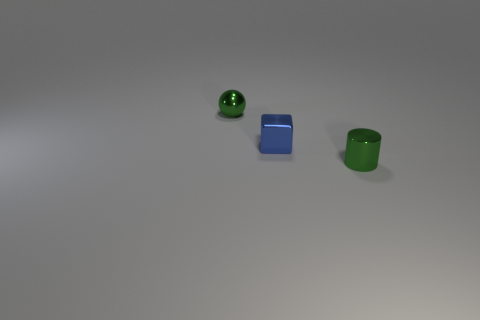What is the size of the object that is the same color as the tiny cylinder?
Your response must be concise. Small. There is a green metallic object on the right side of the metal ball; what number of objects are behind it?
Offer a very short reply. 2. What number of yellow objects are either shiny balls or rubber cylinders?
Give a very brief answer. 0. There is a small green metallic object that is to the left of the tiny green object in front of the green shiny thing to the left of the green cylinder; what shape is it?
Give a very brief answer. Sphere. What color is the cube that is the same size as the green metallic cylinder?
Offer a very short reply. Blue. How many other blue objects are the same shape as the blue metal thing?
Make the answer very short. 0. Does the blue metallic cube have the same size as the object that is behind the tiny blue shiny object?
Keep it short and to the point. Yes. What is the shape of the green metallic thing that is left of the tiny green object on the right side of the green sphere?
Give a very brief answer. Sphere. Are there fewer objects to the right of the cylinder than tiny cylinders?
Your answer should be compact. Yes. There is a metal object that is the same color as the small sphere; what shape is it?
Make the answer very short. Cylinder. 